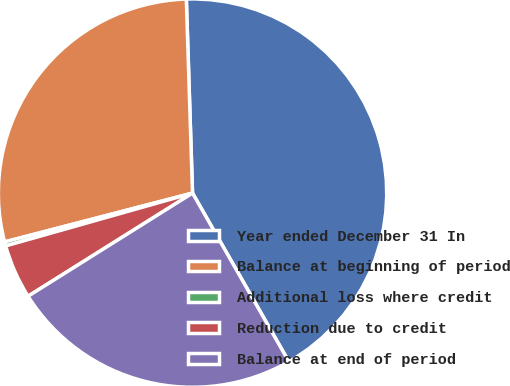<chart> <loc_0><loc_0><loc_500><loc_500><pie_chart><fcel>Year ended December 31 In<fcel>Balance at beginning of period<fcel>Additional loss where credit<fcel>Reduction due to credit<fcel>Balance at end of period<nl><fcel>42.25%<fcel>28.54%<fcel>0.34%<fcel>4.53%<fcel>24.35%<nl></chart> 